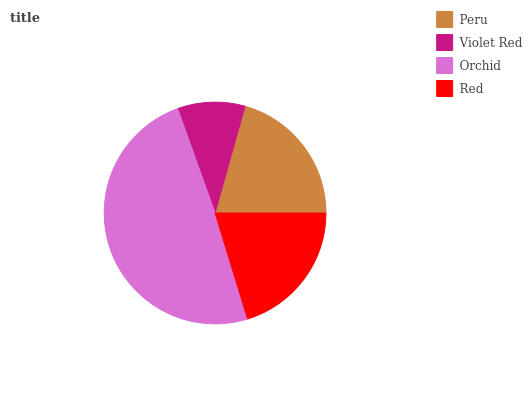Is Violet Red the minimum?
Answer yes or no. Yes. Is Orchid the maximum?
Answer yes or no. Yes. Is Orchid the minimum?
Answer yes or no. No. Is Violet Red the maximum?
Answer yes or no. No. Is Orchid greater than Violet Red?
Answer yes or no. Yes. Is Violet Red less than Orchid?
Answer yes or no. Yes. Is Violet Red greater than Orchid?
Answer yes or no. No. Is Orchid less than Violet Red?
Answer yes or no. No. Is Peru the high median?
Answer yes or no. Yes. Is Red the low median?
Answer yes or no. Yes. Is Orchid the high median?
Answer yes or no. No. Is Violet Red the low median?
Answer yes or no. No. 